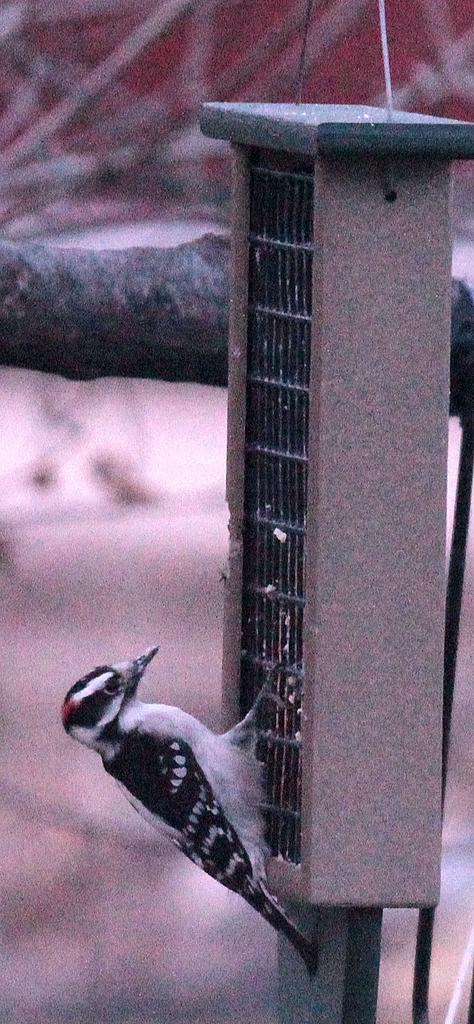What is the main subject of the image? There is a bird in the image. Where is the bird located? The bird is on a pole. What colors can be seen on the bird? The bird has white and black coloring. What can be seen in the background of the image? There is a blurry tree branch in the background of the image. What type of chin can be seen on the jellyfish in the image? There is no jellyfish present in the image; it features a bird on a pole. 